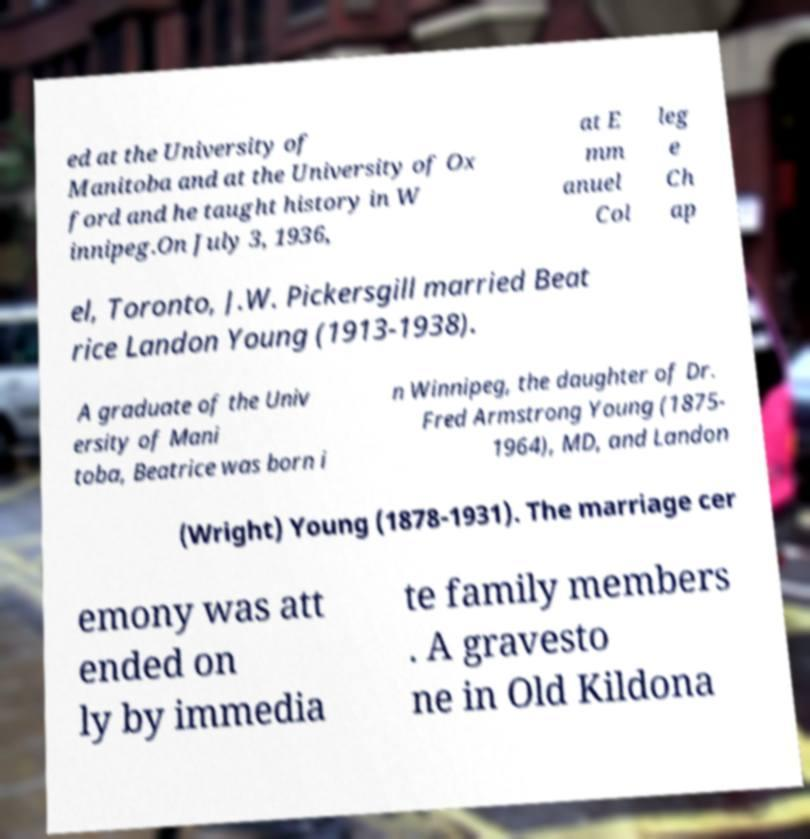Can you read and provide the text displayed in the image?This photo seems to have some interesting text. Can you extract and type it out for me? ed at the University of Manitoba and at the University of Ox ford and he taught history in W innipeg.On July 3, 1936, at E mm anuel Col leg e Ch ap el, Toronto, J.W. Pickersgill married Beat rice Landon Young (1913-1938). A graduate of the Univ ersity of Mani toba, Beatrice was born i n Winnipeg, the daughter of Dr. Fred Armstrong Young (1875- 1964), MD, and Landon (Wright) Young (1878-1931). The marriage cer emony was att ended on ly by immedia te family members . A gravesto ne in Old Kildona 